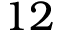Convert formula to latex. <formula><loc_0><loc_0><loc_500><loc_500>1 2</formula> 